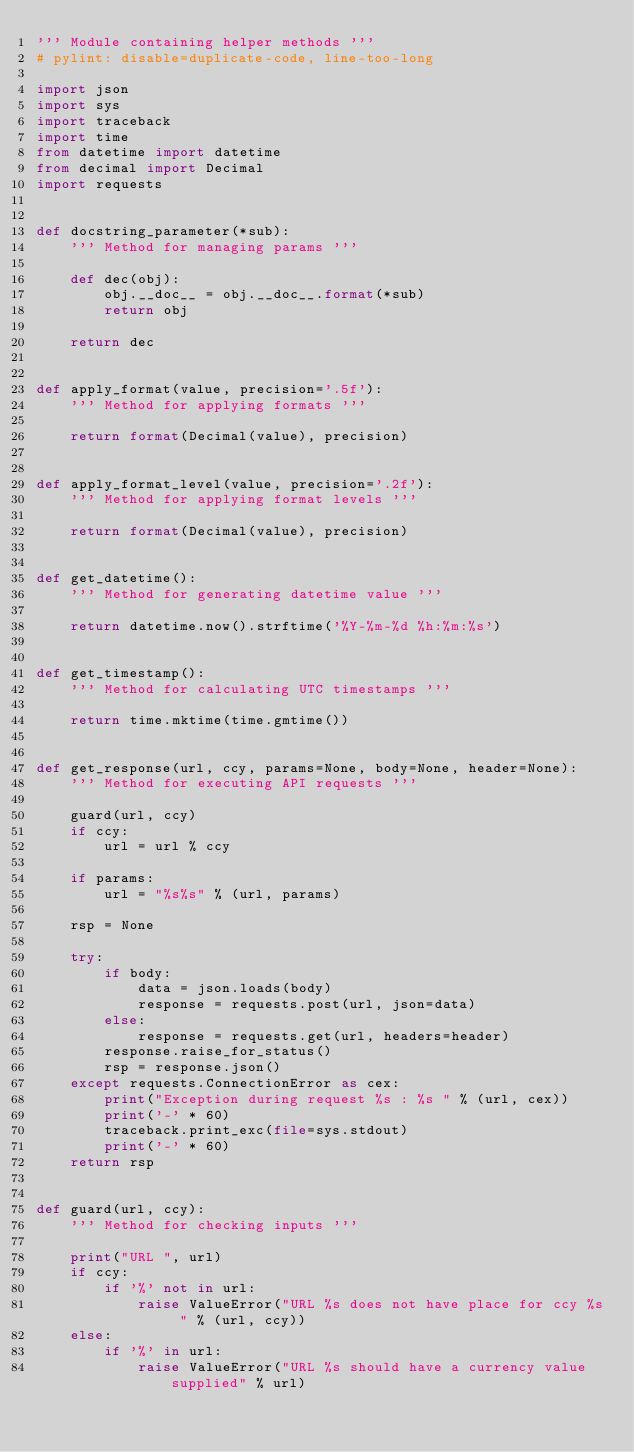<code> <loc_0><loc_0><loc_500><loc_500><_Python_>''' Module containing helper methods '''
# pylint: disable=duplicate-code, line-too-long

import json
import sys
import traceback
import time
from datetime import datetime
from decimal import Decimal
import requests


def docstring_parameter(*sub):
    ''' Method for managing params '''

    def dec(obj):
        obj.__doc__ = obj.__doc__.format(*sub)
        return obj

    return dec


def apply_format(value, precision='.5f'):
    ''' Method for applying formats '''

    return format(Decimal(value), precision)


def apply_format_level(value, precision='.2f'):
    ''' Method for applying format levels '''

    return format(Decimal(value), precision)


def get_datetime():
    ''' Method for generating datetime value '''

    return datetime.now().strftime('%Y-%m-%d %h:%m:%s')


def get_timestamp():
    ''' Method for calculating UTC timestamps '''

    return time.mktime(time.gmtime())


def get_response(url, ccy, params=None, body=None, header=None):
    ''' Method for executing API requests '''

    guard(url, ccy)
    if ccy:
        url = url % ccy

    if params:
        url = "%s%s" % (url, params)

    rsp = None

    try:
        if body:
            data = json.loads(body)
            response = requests.post(url, json=data)
        else:
            response = requests.get(url, headers=header)
        response.raise_for_status()
        rsp = response.json()
    except requests.ConnectionError as cex:
        print("Exception during request %s : %s " % (url, cex))
        print('-' * 60)
        traceback.print_exc(file=sys.stdout)
        print('-' * 60)
    return rsp


def guard(url, ccy):
    ''' Method for checking inputs '''

    print("URL ", url)
    if ccy:
        if '%' not in url:
            raise ValueError("URL %s does not have place for ccy %s " % (url, ccy))
    else:
        if '%' in url:
            raise ValueError("URL %s should have a currency value supplied" % url)
</code> 